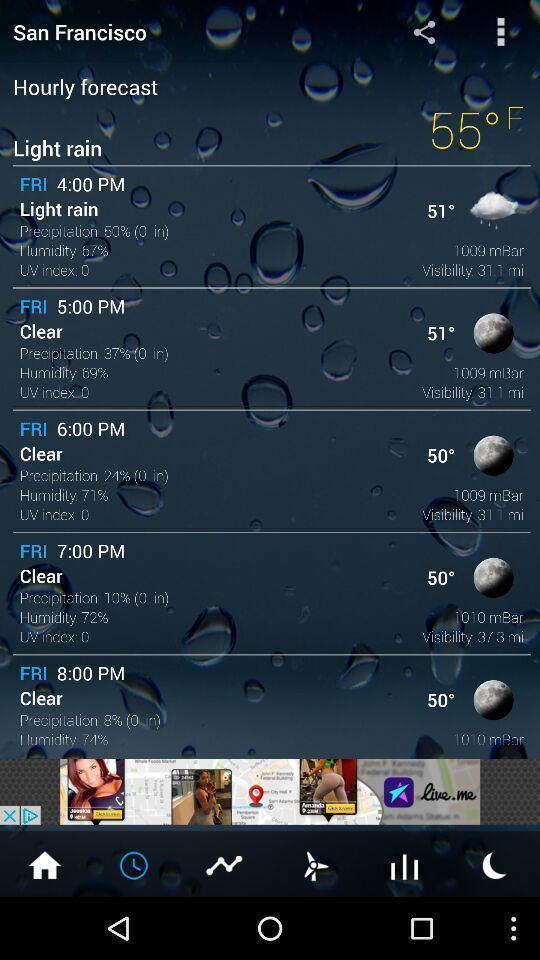Please provide a description for this image. Page displaying weather forecast on weather app. 